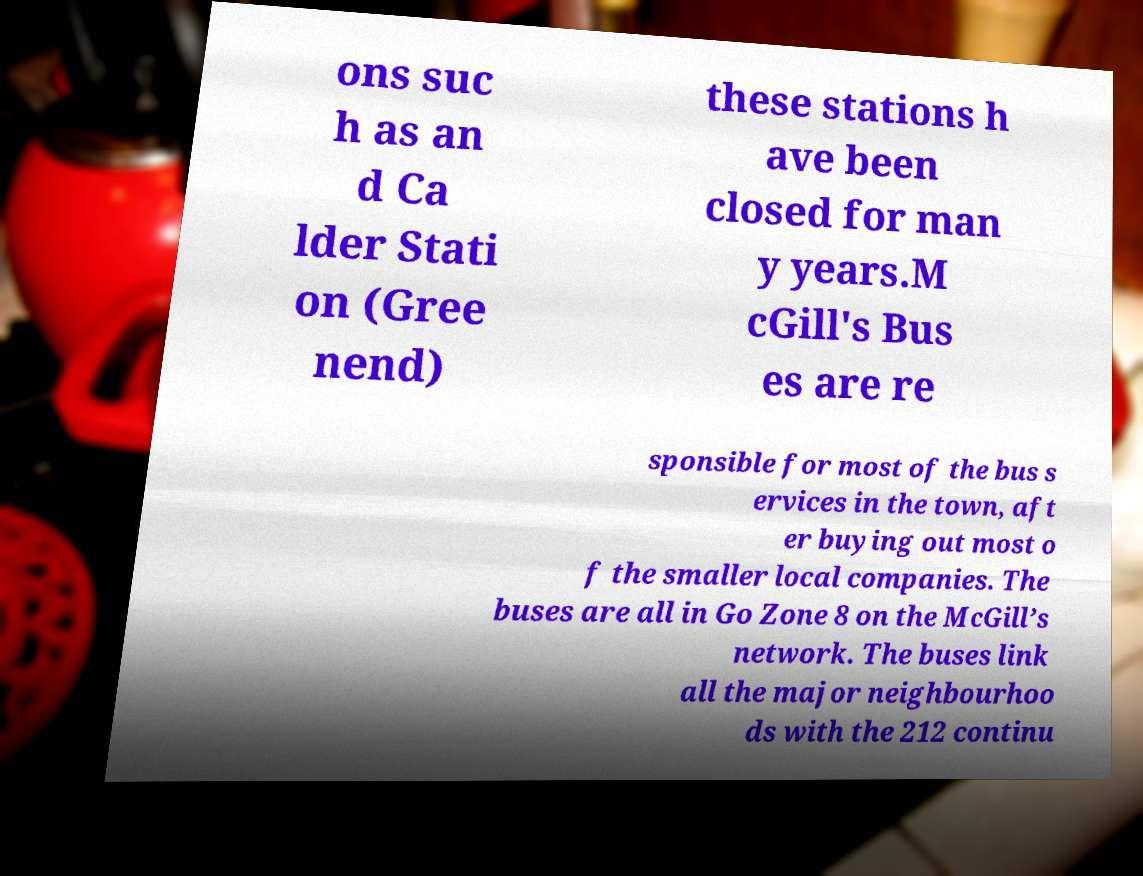Can you read and provide the text displayed in the image?This photo seems to have some interesting text. Can you extract and type it out for me? ons suc h as an d Ca lder Stati on (Gree nend) these stations h ave been closed for man y years.M cGill's Bus es are re sponsible for most of the bus s ervices in the town, aft er buying out most o f the smaller local companies. The buses are all in Go Zone 8 on the McGill’s network. The buses link all the major neighbourhoo ds with the 212 continu 